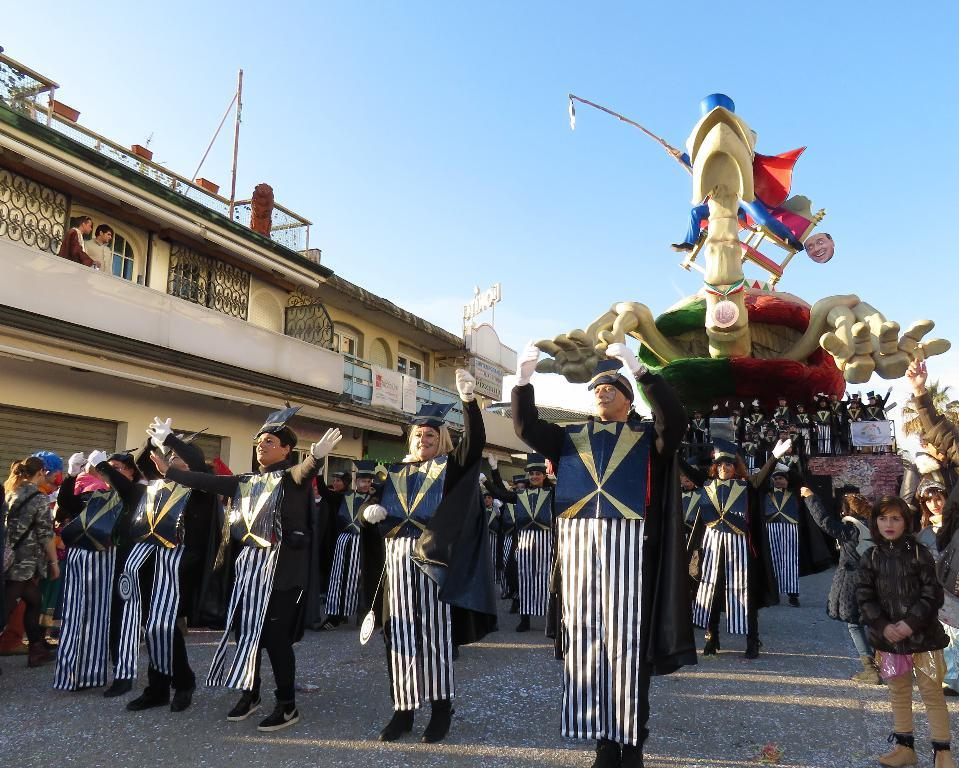What is the main subject of the image? The main subject of the image is a crowd. Are there any other notable objects or structures in the image? Yes, there is a statue and a building with boards in the image. What is the color of the sky in the image? The sky is blue in the image. What type of spring can be seen in the image? There is no spring present in the image. Who is the daughter in the image? There is no mention of a daughter in the image. 